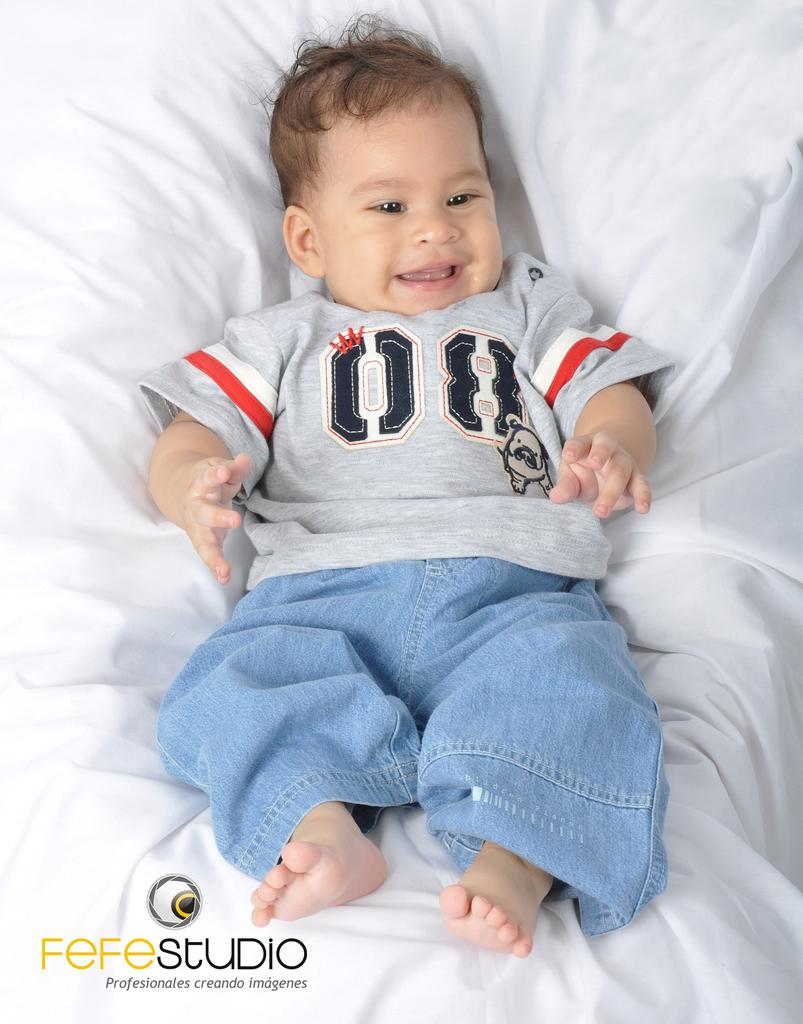What is the main subject of the image? There is a small baby in the image. What is the baby wearing? The baby is wearing a grey t-shirt. Where is the baby located in the image? The baby is lying on a bed. Can you describe any marks or stains on the bed? There is a small water mark on the front bottom side of the bed. What type of farm animals can be seen in the image? There are no farm animals present in the image; it features a small baby lying on a bed. How many stitches are visible on the baby's finger in the image? There are no stitches visible on the baby's finger in the image. 